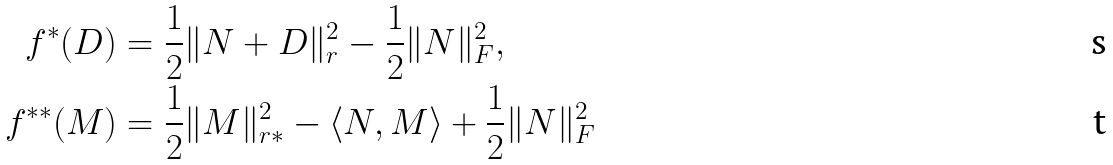<formula> <loc_0><loc_0><loc_500><loc_500>f ^ { \ast } ( D ) & = \frac { 1 } { 2 } \| N + D \| _ { r } ^ { 2 } - \frac { 1 } { 2 } \| N \| _ { F } ^ { 2 } , \\ f ^ { \ast \ast } ( M ) & = \frac { 1 } { 2 } \| M \| _ { r \ast } ^ { 2 } - \langle N , M \rangle + \frac { 1 } { 2 } \| N \| _ { F } ^ { 2 }</formula> 